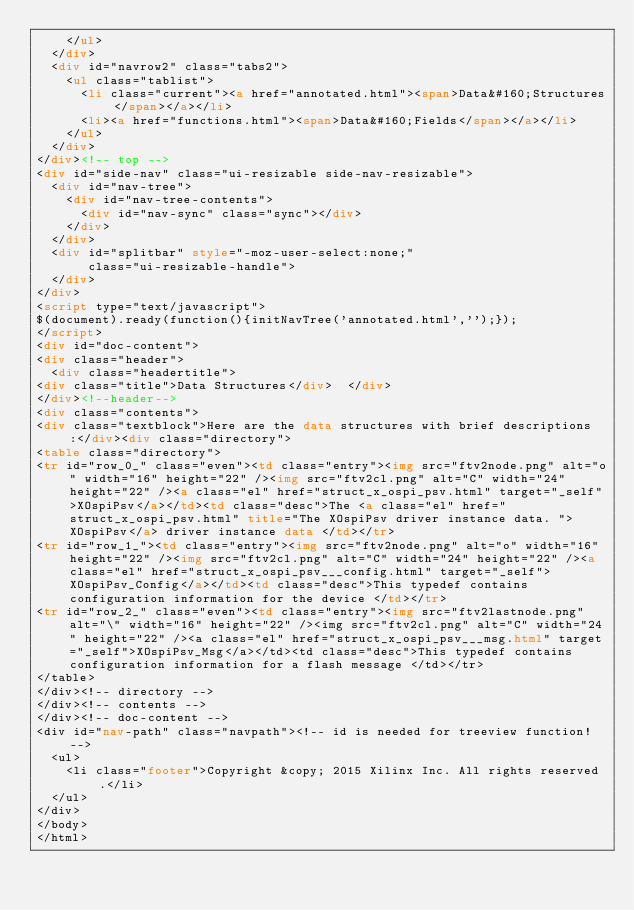Convert code to text. <code><loc_0><loc_0><loc_500><loc_500><_HTML_>    </ul>
  </div>
  <div id="navrow2" class="tabs2">
    <ul class="tablist">
      <li class="current"><a href="annotated.html"><span>Data&#160;Structures</span></a></li>
      <li><a href="functions.html"><span>Data&#160;Fields</span></a></li>
    </ul>
  </div>
</div><!-- top -->
<div id="side-nav" class="ui-resizable side-nav-resizable">
  <div id="nav-tree">
    <div id="nav-tree-contents">
      <div id="nav-sync" class="sync"></div>
    </div>
  </div>
  <div id="splitbar" style="-moz-user-select:none;"
       class="ui-resizable-handle">
  </div>
</div>
<script type="text/javascript">
$(document).ready(function(){initNavTree('annotated.html','');});
</script>
<div id="doc-content">
<div class="header">
  <div class="headertitle">
<div class="title">Data Structures</div>  </div>
</div><!--header-->
<div class="contents">
<div class="textblock">Here are the data structures with brief descriptions:</div><div class="directory">
<table class="directory">
<tr id="row_0_" class="even"><td class="entry"><img src="ftv2node.png" alt="o" width="16" height="22" /><img src="ftv2cl.png" alt="C" width="24" height="22" /><a class="el" href="struct_x_ospi_psv.html" target="_self">XOspiPsv</a></td><td class="desc">The <a class="el" href="struct_x_ospi_psv.html" title="The XOspiPsv driver instance data. ">XOspiPsv</a> driver instance data </td></tr>
<tr id="row_1_"><td class="entry"><img src="ftv2node.png" alt="o" width="16" height="22" /><img src="ftv2cl.png" alt="C" width="24" height="22" /><a class="el" href="struct_x_ospi_psv___config.html" target="_self">XOspiPsv_Config</a></td><td class="desc">This typedef contains configuration information for the device </td></tr>
<tr id="row_2_" class="even"><td class="entry"><img src="ftv2lastnode.png" alt="\" width="16" height="22" /><img src="ftv2cl.png" alt="C" width="24" height="22" /><a class="el" href="struct_x_ospi_psv___msg.html" target="_self">XOspiPsv_Msg</a></td><td class="desc">This typedef contains configuration information for a flash message </td></tr>
</table>
</div><!-- directory -->
</div><!-- contents -->
</div><!-- doc-content -->
<div id="nav-path" class="navpath"><!-- id is needed for treeview function! -->
  <ul>
    <li class="footer">Copyright &copy; 2015 Xilinx Inc. All rights reserved.</li>
  </ul>
</div>
</body>
</html>
</code> 